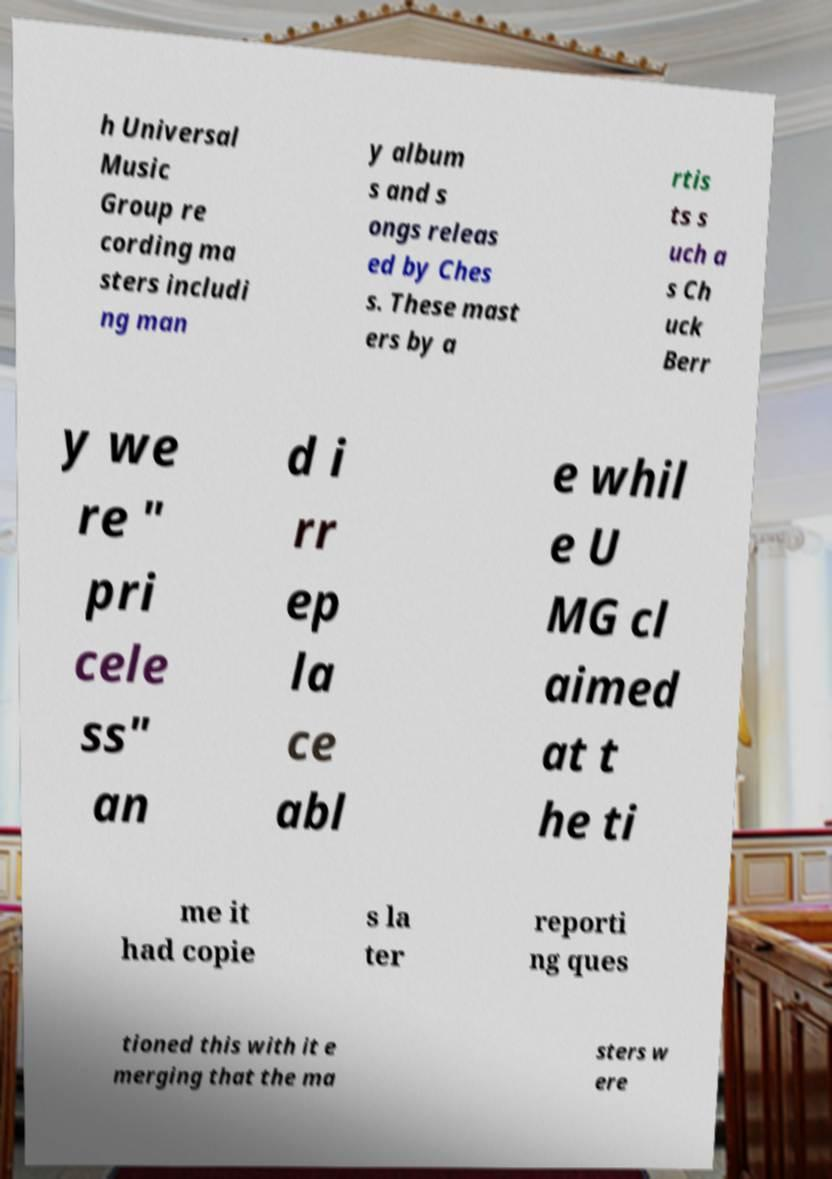I need the written content from this picture converted into text. Can you do that? h Universal Music Group re cording ma sters includi ng man y album s and s ongs releas ed by Ches s. These mast ers by a rtis ts s uch a s Ch uck Berr y we re " pri cele ss" an d i rr ep la ce abl e whil e U MG cl aimed at t he ti me it had copie s la ter reporti ng ques tioned this with it e merging that the ma sters w ere 